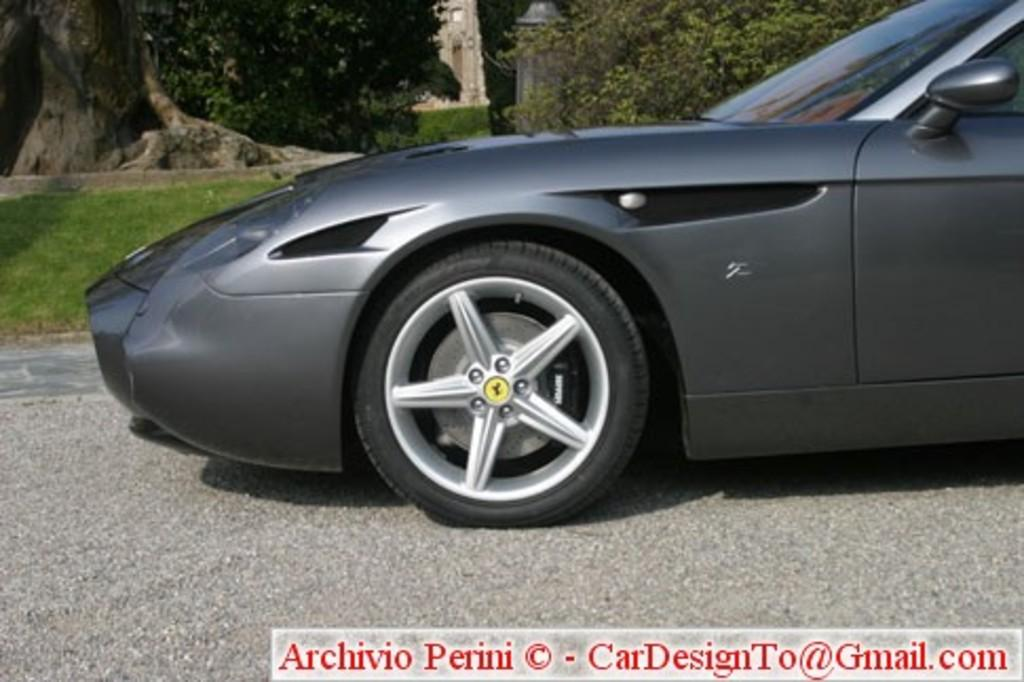What is the main subject in the front of the image? There is a car in the front of the image. What can be seen in the background of the image? There are trees and grass in the background of the image. Is there any text present in the image? Yes, there is some text at the bottom of the image. Can you hear the car laughing in the image? There is no sound or indication of laughter in the image; it is a still image of a car. 